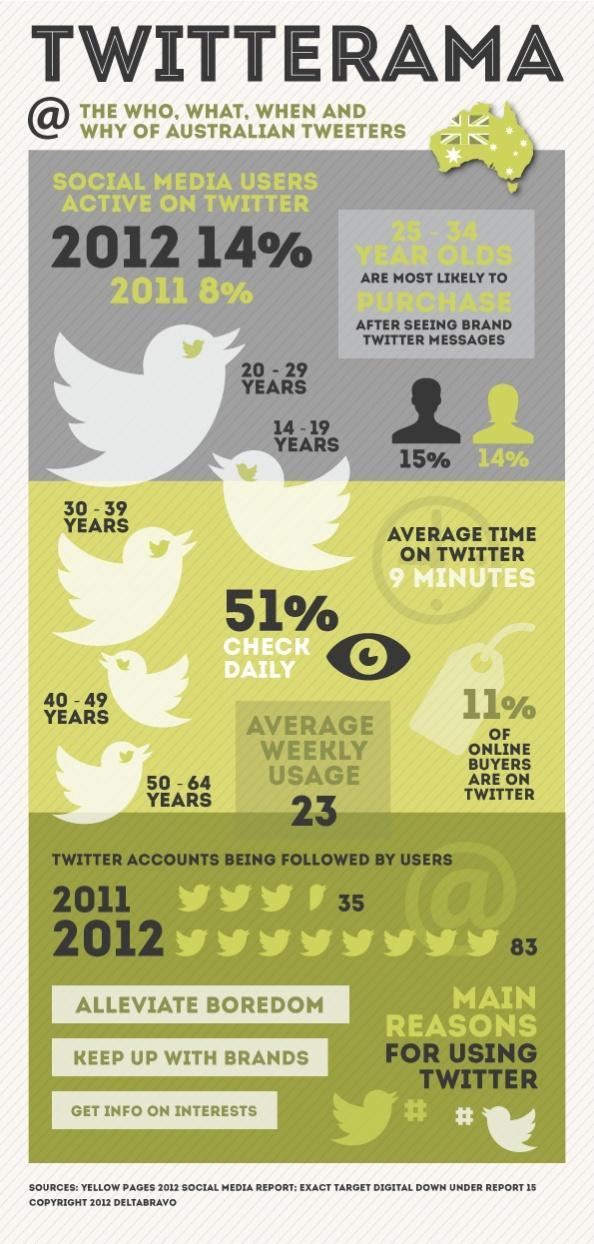How many twitter accounts were followed by the users in Australia in 2012?
Answer the question with a short phrase. 83 What is the oldest age group of Twitter users in Australia in 2012? 50 - 64 YEARS What percentage of social media users in Australia were not active on twitter in 2012? 86% What percentage of social media users in Australia were active on twitter in 2011? 8% What percentage of the Australians check twitter daily in 2012? 51% What percentage of Twitters in Australia are female in 2012? 14% What is the youngest age group of Twitter users in Australia in 2012? 14 - 19 YEARS What percentage of Twitters in Australia are male in 2012? 15% 